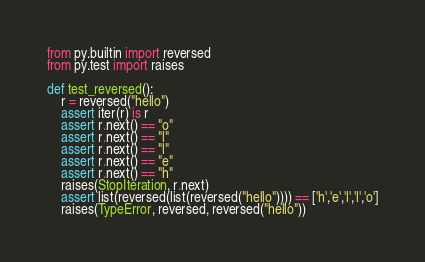<code> <loc_0><loc_0><loc_500><loc_500><_Python_>from py.builtin import reversed
from py.test import raises

def test_reversed():
    r = reversed("hello")
    assert iter(r) is r
    assert r.next() == "o"
    assert r.next() == "l"
    assert r.next() == "l"
    assert r.next() == "e"
    assert r.next() == "h"
    raises(StopIteration, r.next)
    assert list(reversed(list(reversed("hello")))) == ['h','e','l','l','o']
    raises(TypeError, reversed, reversed("hello"))
</code> 